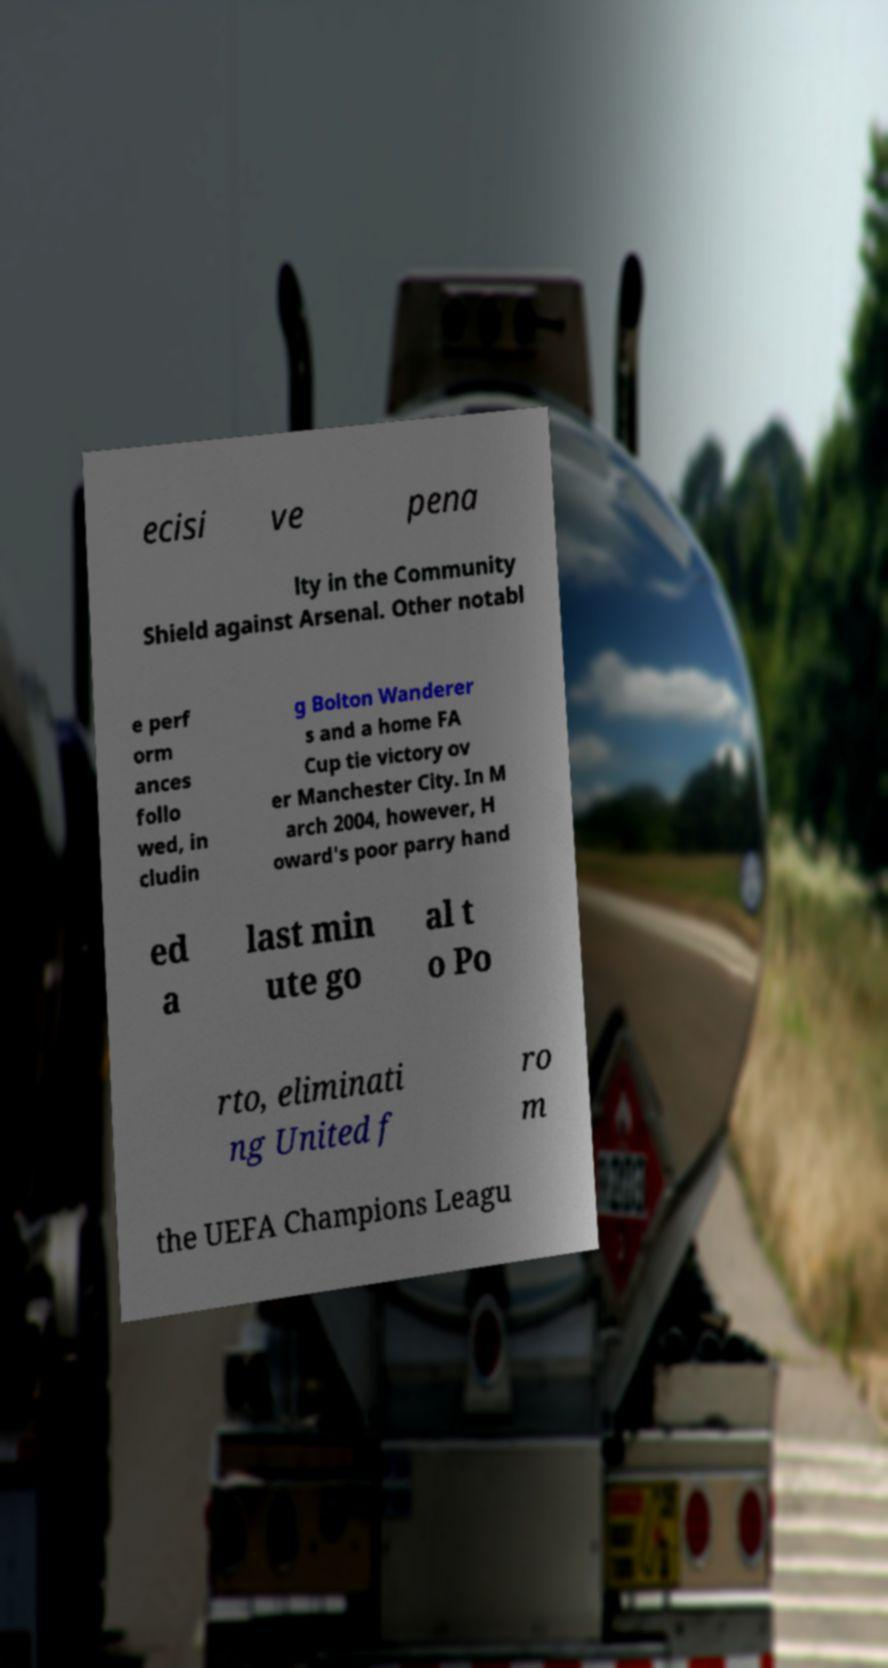I need the written content from this picture converted into text. Can you do that? ecisi ve pena lty in the Community Shield against Arsenal. Other notabl e perf orm ances follo wed, in cludin g Bolton Wanderer s and a home FA Cup tie victory ov er Manchester City. In M arch 2004, however, H oward's poor parry hand ed a last min ute go al t o Po rto, eliminati ng United f ro m the UEFA Champions Leagu 